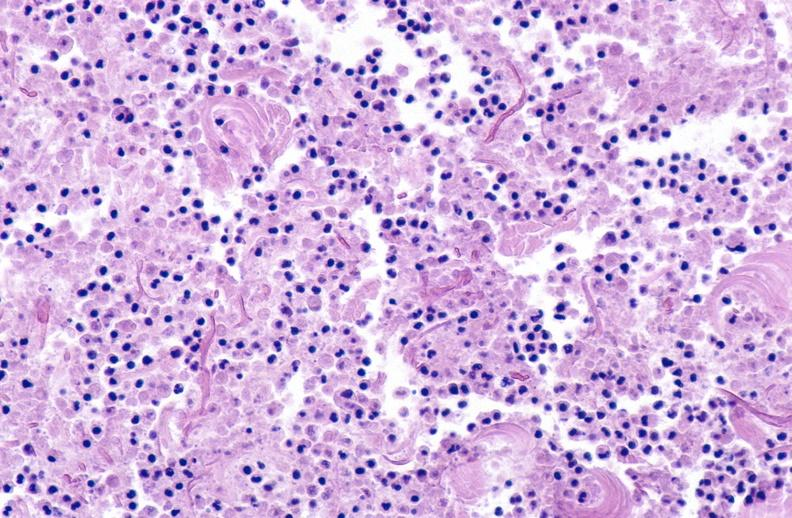what does this image show?
Answer the question using a single word or phrase. Panniculitis and fascitis 